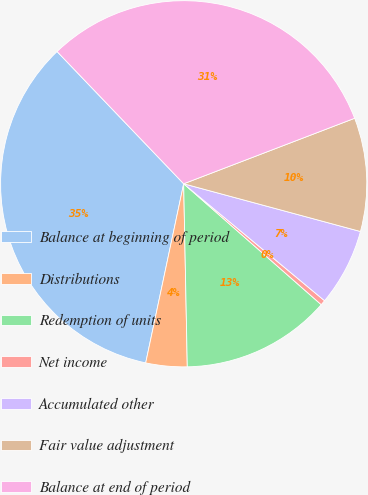<chart> <loc_0><loc_0><loc_500><loc_500><pie_chart><fcel>Balance at beginning of period<fcel>Distributions<fcel>Redemption of units<fcel>Net income<fcel>Accumulated other<fcel>Fair value adjustment<fcel>Balance at end of period<nl><fcel>34.52%<fcel>3.64%<fcel>13.21%<fcel>0.45%<fcel>6.83%<fcel>10.02%<fcel>31.33%<nl></chart> 